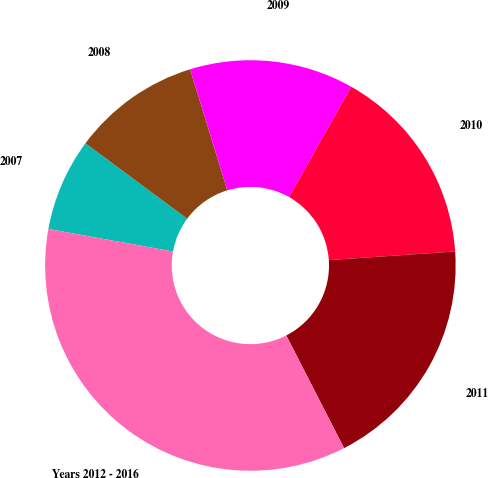Convert chart. <chart><loc_0><loc_0><loc_500><loc_500><pie_chart><fcel>2007<fcel>2008<fcel>2009<fcel>2010<fcel>2011<fcel>Years 2012 - 2016<nl><fcel>7.3%<fcel>10.11%<fcel>12.92%<fcel>15.73%<fcel>18.54%<fcel>35.39%<nl></chart> 